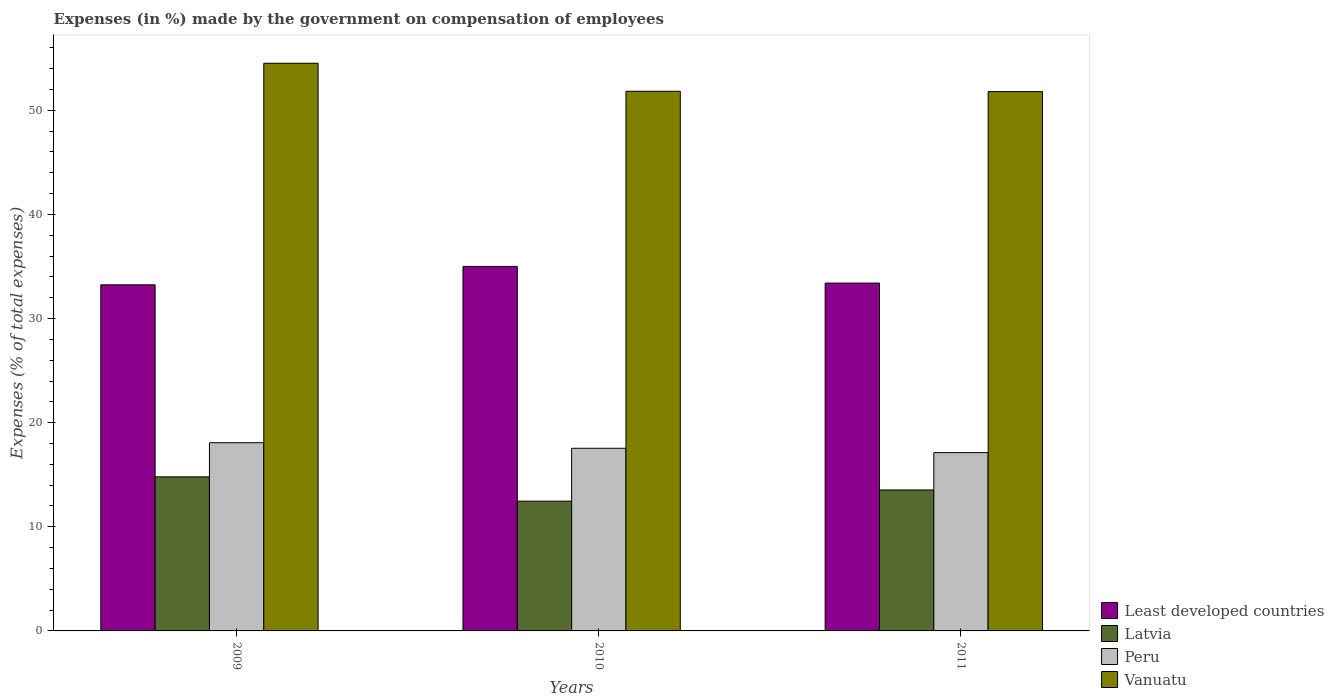How many groups of bars are there?
Offer a terse response. 3. Are the number of bars per tick equal to the number of legend labels?
Your answer should be compact. Yes. How many bars are there on the 1st tick from the left?
Ensure brevity in your answer.  4. What is the label of the 1st group of bars from the left?
Your answer should be very brief. 2009. What is the percentage of expenses made by the government on compensation of employees in Latvia in 2011?
Your answer should be compact. 13.54. Across all years, what is the maximum percentage of expenses made by the government on compensation of employees in Latvia?
Your answer should be very brief. 14.8. Across all years, what is the minimum percentage of expenses made by the government on compensation of employees in Vanuatu?
Provide a short and direct response. 51.8. In which year was the percentage of expenses made by the government on compensation of employees in Vanuatu minimum?
Offer a very short reply. 2011. What is the total percentage of expenses made by the government on compensation of employees in Vanuatu in the graph?
Your answer should be compact. 158.14. What is the difference between the percentage of expenses made by the government on compensation of employees in Least developed countries in 2009 and that in 2010?
Your response must be concise. -1.77. What is the difference between the percentage of expenses made by the government on compensation of employees in Peru in 2011 and the percentage of expenses made by the government on compensation of employees in Vanuatu in 2009?
Your answer should be very brief. -37.39. What is the average percentage of expenses made by the government on compensation of employees in Vanuatu per year?
Your answer should be compact. 52.71. In the year 2011, what is the difference between the percentage of expenses made by the government on compensation of employees in Vanuatu and percentage of expenses made by the government on compensation of employees in Peru?
Offer a very short reply. 34.67. What is the ratio of the percentage of expenses made by the government on compensation of employees in Least developed countries in 2009 to that in 2010?
Your response must be concise. 0.95. Is the difference between the percentage of expenses made by the government on compensation of employees in Vanuatu in 2010 and 2011 greater than the difference between the percentage of expenses made by the government on compensation of employees in Peru in 2010 and 2011?
Offer a very short reply. No. What is the difference between the highest and the second highest percentage of expenses made by the government on compensation of employees in Latvia?
Offer a terse response. 1.26. What is the difference between the highest and the lowest percentage of expenses made by the government on compensation of employees in Peru?
Offer a very short reply. 0.95. Is the sum of the percentage of expenses made by the government on compensation of employees in Latvia in 2009 and 2010 greater than the maximum percentage of expenses made by the government on compensation of employees in Least developed countries across all years?
Give a very brief answer. No. Is it the case that in every year, the sum of the percentage of expenses made by the government on compensation of employees in Least developed countries and percentage of expenses made by the government on compensation of employees in Vanuatu is greater than the sum of percentage of expenses made by the government on compensation of employees in Latvia and percentage of expenses made by the government on compensation of employees in Peru?
Ensure brevity in your answer.  Yes. What does the 3rd bar from the left in 2011 represents?
Provide a succinct answer. Peru. What does the 4th bar from the right in 2011 represents?
Keep it short and to the point. Least developed countries. Is it the case that in every year, the sum of the percentage of expenses made by the government on compensation of employees in Latvia and percentage of expenses made by the government on compensation of employees in Vanuatu is greater than the percentage of expenses made by the government on compensation of employees in Least developed countries?
Your response must be concise. Yes. Does the graph contain any zero values?
Ensure brevity in your answer.  No. How many legend labels are there?
Make the answer very short. 4. How are the legend labels stacked?
Provide a succinct answer. Vertical. What is the title of the graph?
Your response must be concise. Expenses (in %) made by the government on compensation of employees. Does "Other small states" appear as one of the legend labels in the graph?
Make the answer very short. No. What is the label or title of the Y-axis?
Offer a terse response. Expenses (% of total expenses). What is the Expenses (% of total expenses) of Least developed countries in 2009?
Your answer should be compact. 33.24. What is the Expenses (% of total expenses) of Latvia in 2009?
Offer a terse response. 14.8. What is the Expenses (% of total expenses) in Peru in 2009?
Offer a very short reply. 18.08. What is the Expenses (% of total expenses) in Vanuatu in 2009?
Your answer should be compact. 54.52. What is the Expenses (% of total expenses) of Least developed countries in 2010?
Offer a very short reply. 35.01. What is the Expenses (% of total expenses) of Latvia in 2010?
Your response must be concise. 12.46. What is the Expenses (% of total expenses) of Peru in 2010?
Provide a succinct answer. 17.54. What is the Expenses (% of total expenses) in Vanuatu in 2010?
Keep it short and to the point. 51.83. What is the Expenses (% of total expenses) of Least developed countries in 2011?
Provide a short and direct response. 33.4. What is the Expenses (% of total expenses) in Latvia in 2011?
Ensure brevity in your answer.  13.54. What is the Expenses (% of total expenses) in Peru in 2011?
Make the answer very short. 17.12. What is the Expenses (% of total expenses) in Vanuatu in 2011?
Provide a succinct answer. 51.8. Across all years, what is the maximum Expenses (% of total expenses) in Least developed countries?
Ensure brevity in your answer.  35.01. Across all years, what is the maximum Expenses (% of total expenses) of Latvia?
Offer a very short reply. 14.8. Across all years, what is the maximum Expenses (% of total expenses) in Peru?
Provide a short and direct response. 18.08. Across all years, what is the maximum Expenses (% of total expenses) in Vanuatu?
Your answer should be very brief. 54.52. Across all years, what is the minimum Expenses (% of total expenses) of Least developed countries?
Provide a short and direct response. 33.24. Across all years, what is the minimum Expenses (% of total expenses) in Latvia?
Provide a short and direct response. 12.46. Across all years, what is the minimum Expenses (% of total expenses) of Peru?
Make the answer very short. 17.12. Across all years, what is the minimum Expenses (% of total expenses) in Vanuatu?
Offer a terse response. 51.8. What is the total Expenses (% of total expenses) in Least developed countries in the graph?
Your answer should be compact. 101.65. What is the total Expenses (% of total expenses) in Latvia in the graph?
Ensure brevity in your answer.  40.8. What is the total Expenses (% of total expenses) in Peru in the graph?
Provide a short and direct response. 52.74. What is the total Expenses (% of total expenses) of Vanuatu in the graph?
Offer a very short reply. 158.14. What is the difference between the Expenses (% of total expenses) in Least developed countries in 2009 and that in 2010?
Make the answer very short. -1.77. What is the difference between the Expenses (% of total expenses) in Latvia in 2009 and that in 2010?
Offer a very short reply. 2.33. What is the difference between the Expenses (% of total expenses) in Peru in 2009 and that in 2010?
Offer a terse response. 0.53. What is the difference between the Expenses (% of total expenses) of Vanuatu in 2009 and that in 2010?
Provide a short and direct response. 2.69. What is the difference between the Expenses (% of total expenses) in Least developed countries in 2009 and that in 2011?
Your answer should be compact. -0.17. What is the difference between the Expenses (% of total expenses) of Latvia in 2009 and that in 2011?
Your answer should be compact. 1.26. What is the difference between the Expenses (% of total expenses) in Peru in 2009 and that in 2011?
Keep it short and to the point. 0.95. What is the difference between the Expenses (% of total expenses) of Vanuatu in 2009 and that in 2011?
Offer a terse response. 2.72. What is the difference between the Expenses (% of total expenses) in Least developed countries in 2010 and that in 2011?
Give a very brief answer. 1.6. What is the difference between the Expenses (% of total expenses) of Latvia in 2010 and that in 2011?
Offer a terse response. -1.07. What is the difference between the Expenses (% of total expenses) of Peru in 2010 and that in 2011?
Offer a very short reply. 0.42. What is the difference between the Expenses (% of total expenses) of Vanuatu in 2010 and that in 2011?
Provide a short and direct response. 0.03. What is the difference between the Expenses (% of total expenses) in Least developed countries in 2009 and the Expenses (% of total expenses) in Latvia in 2010?
Offer a terse response. 20.78. What is the difference between the Expenses (% of total expenses) in Least developed countries in 2009 and the Expenses (% of total expenses) in Peru in 2010?
Give a very brief answer. 15.7. What is the difference between the Expenses (% of total expenses) in Least developed countries in 2009 and the Expenses (% of total expenses) in Vanuatu in 2010?
Offer a terse response. -18.59. What is the difference between the Expenses (% of total expenses) of Latvia in 2009 and the Expenses (% of total expenses) of Peru in 2010?
Ensure brevity in your answer.  -2.74. What is the difference between the Expenses (% of total expenses) of Latvia in 2009 and the Expenses (% of total expenses) of Vanuatu in 2010?
Make the answer very short. -37.03. What is the difference between the Expenses (% of total expenses) in Peru in 2009 and the Expenses (% of total expenses) in Vanuatu in 2010?
Ensure brevity in your answer.  -33.75. What is the difference between the Expenses (% of total expenses) in Least developed countries in 2009 and the Expenses (% of total expenses) in Latvia in 2011?
Offer a terse response. 19.7. What is the difference between the Expenses (% of total expenses) in Least developed countries in 2009 and the Expenses (% of total expenses) in Peru in 2011?
Keep it short and to the point. 16.11. What is the difference between the Expenses (% of total expenses) of Least developed countries in 2009 and the Expenses (% of total expenses) of Vanuatu in 2011?
Provide a short and direct response. -18.56. What is the difference between the Expenses (% of total expenses) in Latvia in 2009 and the Expenses (% of total expenses) in Peru in 2011?
Keep it short and to the point. -2.33. What is the difference between the Expenses (% of total expenses) of Latvia in 2009 and the Expenses (% of total expenses) of Vanuatu in 2011?
Make the answer very short. -37. What is the difference between the Expenses (% of total expenses) in Peru in 2009 and the Expenses (% of total expenses) in Vanuatu in 2011?
Ensure brevity in your answer.  -33.72. What is the difference between the Expenses (% of total expenses) of Least developed countries in 2010 and the Expenses (% of total expenses) of Latvia in 2011?
Your answer should be compact. 21.47. What is the difference between the Expenses (% of total expenses) in Least developed countries in 2010 and the Expenses (% of total expenses) in Peru in 2011?
Keep it short and to the point. 17.88. What is the difference between the Expenses (% of total expenses) of Least developed countries in 2010 and the Expenses (% of total expenses) of Vanuatu in 2011?
Your answer should be very brief. -16.79. What is the difference between the Expenses (% of total expenses) of Latvia in 2010 and the Expenses (% of total expenses) of Peru in 2011?
Offer a terse response. -4.66. What is the difference between the Expenses (% of total expenses) in Latvia in 2010 and the Expenses (% of total expenses) in Vanuatu in 2011?
Your answer should be compact. -39.34. What is the difference between the Expenses (% of total expenses) in Peru in 2010 and the Expenses (% of total expenses) in Vanuatu in 2011?
Give a very brief answer. -34.26. What is the average Expenses (% of total expenses) of Least developed countries per year?
Provide a short and direct response. 33.88. What is the average Expenses (% of total expenses) of Latvia per year?
Provide a succinct answer. 13.6. What is the average Expenses (% of total expenses) of Peru per year?
Provide a succinct answer. 17.58. What is the average Expenses (% of total expenses) of Vanuatu per year?
Your answer should be very brief. 52.71. In the year 2009, what is the difference between the Expenses (% of total expenses) in Least developed countries and Expenses (% of total expenses) in Latvia?
Make the answer very short. 18.44. In the year 2009, what is the difference between the Expenses (% of total expenses) in Least developed countries and Expenses (% of total expenses) in Peru?
Offer a terse response. 15.16. In the year 2009, what is the difference between the Expenses (% of total expenses) in Least developed countries and Expenses (% of total expenses) in Vanuatu?
Your answer should be compact. -21.28. In the year 2009, what is the difference between the Expenses (% of total expenses) of Latvia and Expenses (% of total expenses) of Peru?
Make the answer very short. -3.28. In the year 2009, what is the difference between the Expenses (% of total expenses) in Latvia and Expenses (% of total expenses) in Vanuatu?
Your answer should be compact. -39.72. In the year 2009, what is the difference between the Expenses (% of total expenses) of Peru and Expenses (% of total expenses) of Vanuatu?
Make the answer very short. -36.44. In the year 2010, what is the difference between the Expenses (% of total expenses) of Least developed countries and Expenses (% of total expenses) of Latvia?
Offer a terse response. 22.54. In the year 2010, what is the difference between the Expenses (% of total expenses) of Least developed countries and Expenses (% of total expenses) of Peru?
Keep it short and to the point. 17.47. In the year 2010, what is the difference between the Expenses (% of total expenses) of Least developed countries and Expenses (% of total expenses) of Vanuatu?
Your answer should be compact. -16.82. In the year 2010, what is the difference between the Expenses (% of total expenses) in Latvia and Expenses (% of total expenses) in Peru?
Your answer should be very brief. -5.08. In the year 2010, what is the difference between the Expenses (% of total expenses) in Latvia and Expenses (% of total expenses) in Vanuatu?
Give a very brief answer. -39.37. In the year 2010, what is the difference between the Expenses (% of total expenses) of Peru and Expenses (% of total expenses) of Vanuatu?
Give a very brief answer. -34.29. In the year 2011, what is the difference between the Expenses (% of total expenses) in Least developed countries and Expenses (% of total expenses) in Latvia?
Your answer should be compact. 19.87. In the year 2011, what is the difference between the Expenses (% of total expenses) of Least developed countries and Expenses (% of total expenses) of Peru?
Provide a succinct answer. 16.28. In the year 2011, what is the difference between the Expenses (% of total expenses) of Least developed countries and Expenses (% of total expenses) of Vanuatu?
Provide a short and direct response. -18.39. In the year 2011, what is the difference between the Expenses (% of total expenses) of Latvia and Expenses (% of total expenses) of Peru?
Provide a succinct answer. -3.59. In the year 2011, what is the difference between the Expenses (% of total expenses) in Latvia and Expenses (% of total expenses) in Vanuatu?
Make the answer very short. -38.26. In the year 2011, what is the difference between the Expenses (% of total expenses) of Peru and Expenses (% of total expenses) of Vanuatu?
Give a very brief answer. -34.67. What is the ratio of the Expenses (% of total expenses) in Least developed countries in 2009 to that in 2010?
Provide a short and direct response. 0.95. What is the ratio of the Expenses (% of total expenses) of Latvia in 2009 to that in 2010?
Provide a short and direct response. 1.19. What is the ratio of the Expenses (% of total expenses) in Peru in 2009 to that in 2010?
Your answer should be very brief. 1.03. What is the ratio of the Expenses (% of total expenses) in Vanuatu in 2009 to that in 2010?
Provide a short and direct response. 1.05. What is the ratio of the Expenses (% of total expenses) in Latvia in 2009 to that in 2011?
Provide a short and direct response. 1.09. What is the ratio of the Expenses (% of total expenses) of Peru in 2009 to that in 2011?
Offer a very short reply. 1.06. What is the ratio of the Expenses (% of total expenses) of Vanuatu in 2009 to that in 2011?
Give a very brief answer. 1.05. What is the ratio of the Expenses (% of total expenses) in Least developed countries in 2010 to that in 2011?
Ensure brevity in your answer.  1.05. What is the ratio of the Expenses (% of total expenses) of Latvia in 2010 to that in 2011?
Offer a very short reply. 0.92. What is the ratio of the Expenses (% of total expenses) in Peru in 2010 to that in 2011?
Offer a terse response. 1.02. What is the difference between the highest and the second highest Expenses (% of total expenses) of Least developed countries?
Keep it short and to the point. 1.6. What is the difference between the highest and the second highest Expenses (% of total expenses) in Latvia?
Give a very brief answer. 1.26. What is the difference between the highest and the second highest Expenses (% of total expenses) of Peru?
Give a very brief answer. 0.53. What is the difference between the highest and the second highest Expenses (% of total expenses) of Vanuatu?
Your answer should be very brief. 2.69. What is the difference between the highest and the lowest Expenses (% of total expenses) of Least developed countries?
Offer a terse response. 1.77. What is the difference between the highest and the lowest Expenses (% of total expenses) of Latvia?
Keep it short and to the point. 2.33. What is the difference between the highest and the lowest Expenses (% of total expenses) in Peru?
Give a very brief answer. 0.95. What is the difference between the highest and the lowest Expenses (% of total expenses) in Vanuatu?
Make the answer very short. 2.72. 